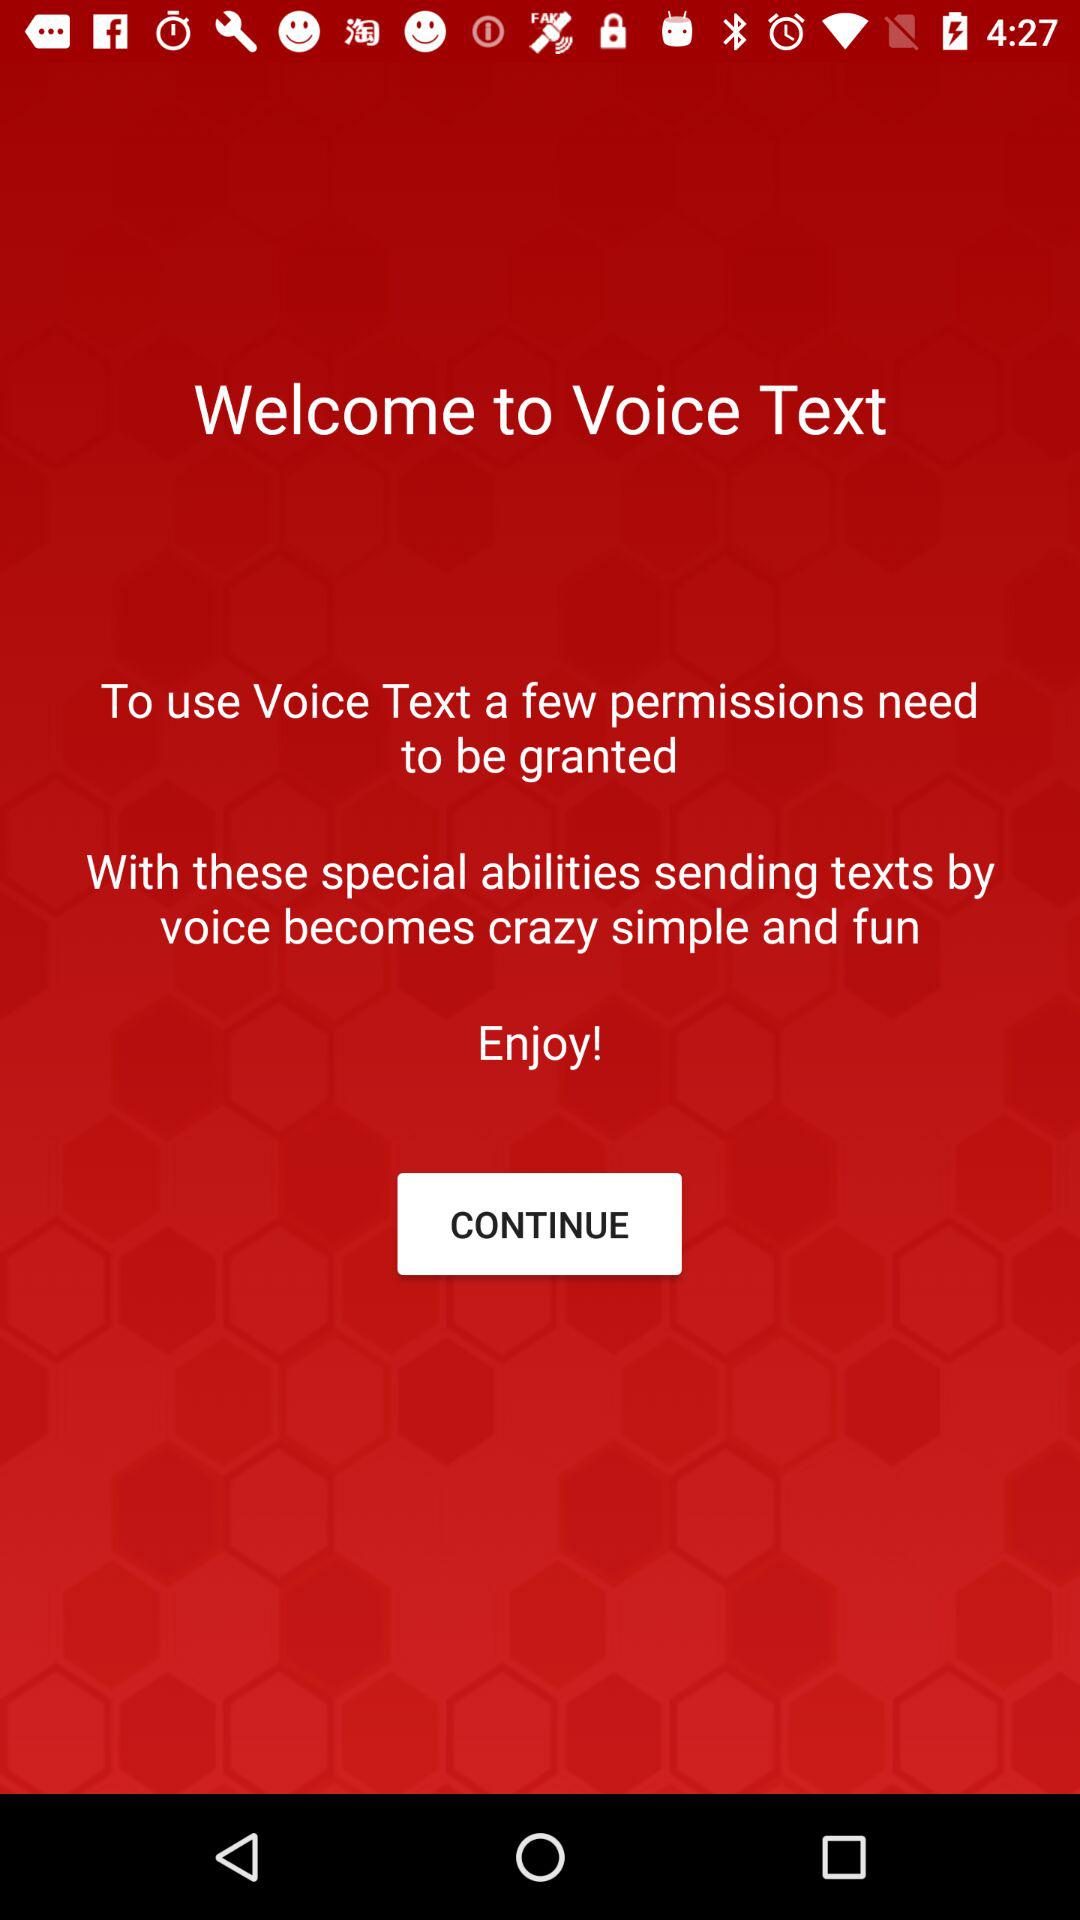Who developed the "Voice Text" app?
When the provided information is insufficient, respond with <no answer>. <no answer> 